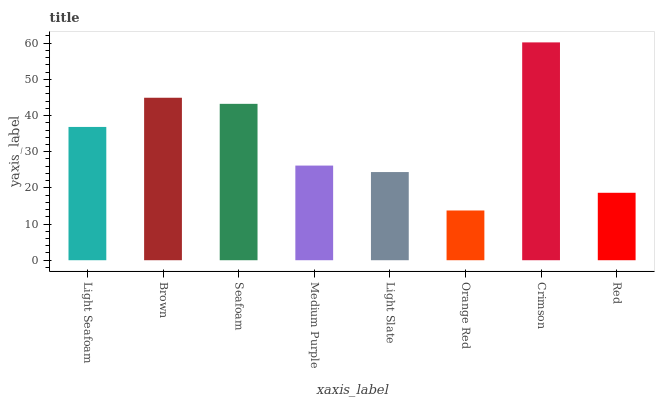Is Orange Red the minimum?
Answer yes or no. Yes. Is Crimson the maximum?
Answer yes or no. Yes. Is Brown the minimum?
Answer yes or no. No. Is Brown the maximum?
Answer yes or no. No. Is Brown greater than Light Seafoam?
Answer yes or no. Yes. Is Light Seafoam less than Brown?
Answer yes or no. Yes. Is Light Seafoam greater than Brown?
Answer yes or no. No. Is Brown less than Light Seafoam?
Answer yes or no. No. Is Light Seafoam the high median?
Answer yes or no. Yes. Is Medium Purple the low median?
Answer yes or no. Yes. Is Brown the high median?
Answer yes or no. No. Is Crimson the low median?
Answer yes or no. No. 